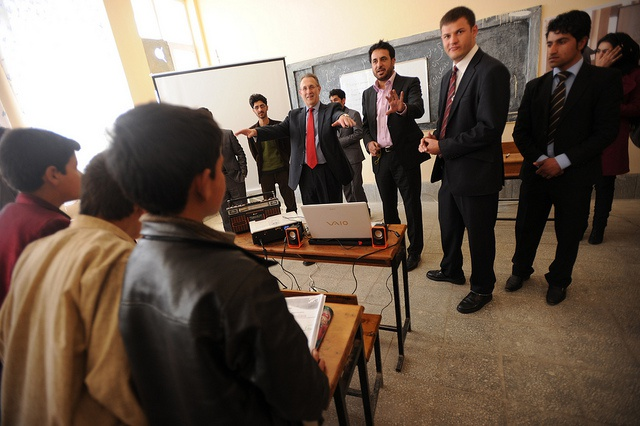Describe the objects in this image and their specific colors. I can see people in lightgray, black, gray, maroon, and darkgray tones, people in lightgray, maroon, black, and gray tones, people in lightgray, black, maroon, and gray tones, people in lightgray, black, gray, maroon, and brown tones, and people in lightgray, black, lightpink, maroon, and brown tones in this image. 